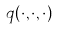Convert formula to latex. <formula><loc_0><loc_0><loc_500><loc_500>q ( \cdot , \cdot , \cdot )</formula> 